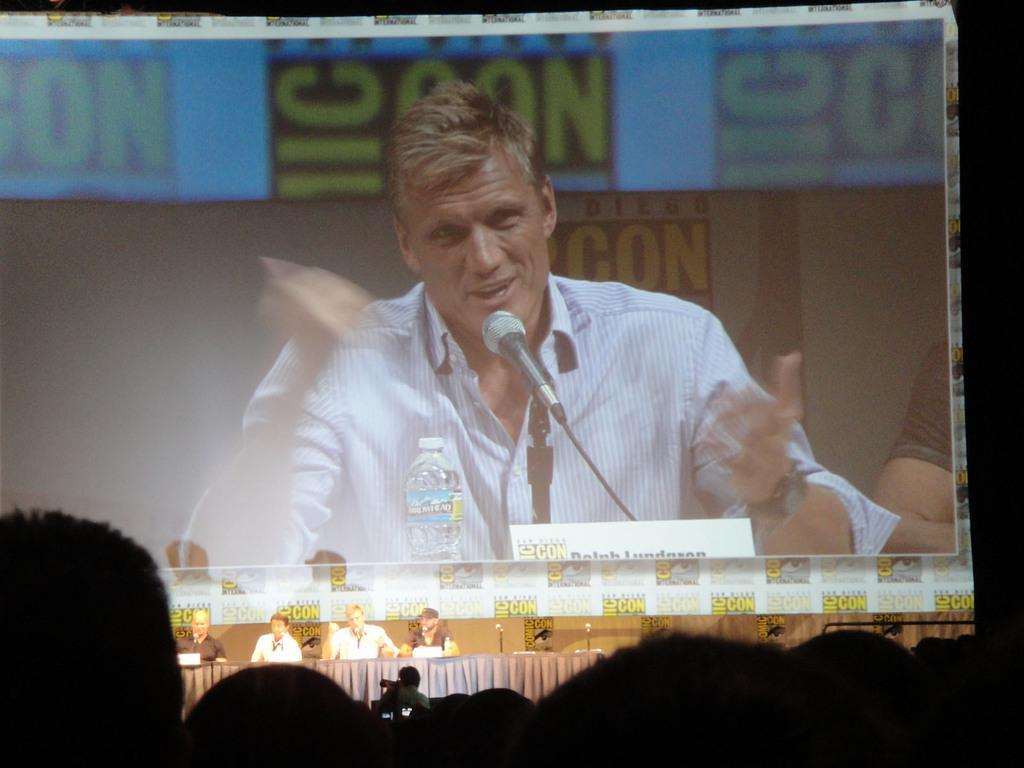Describe this image in one or two sentences. In this picture we can see stage some people are sitting and talking, that is displayed on the display board. 